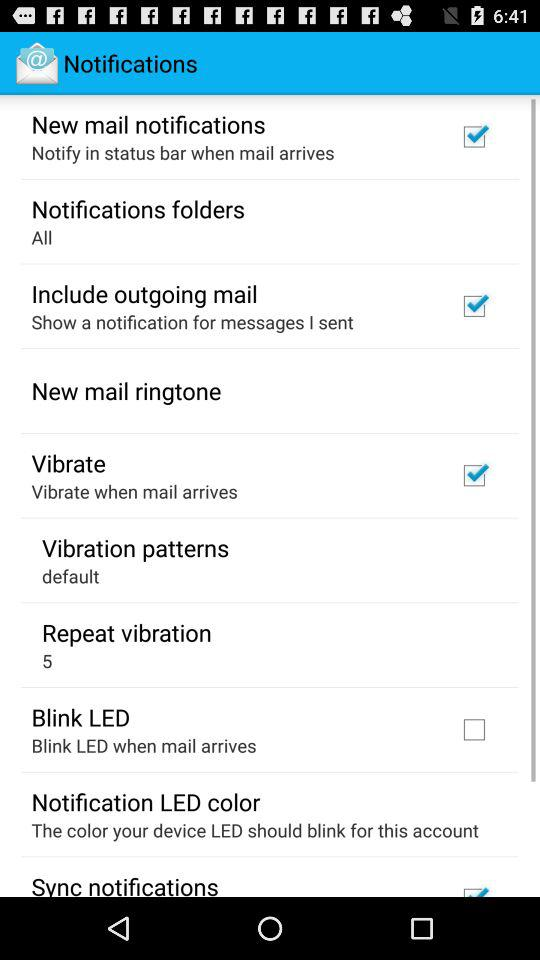What's the status of the "Vibrate"? The status is "on". 